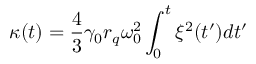Convert formula to latex. <formula><loc_0><loc_0><loc_500><loc_500>\kappa ( t ) = \frac { 4 } { 3 } \gamma _ { 0 } r _ { q } \omega _ { 0 } ^ { 2 } \int _ { 0 } ^ { t } \xi ^ { 2 } ( t ^ { \prime } ) d t ^ { \prime }</formula> 